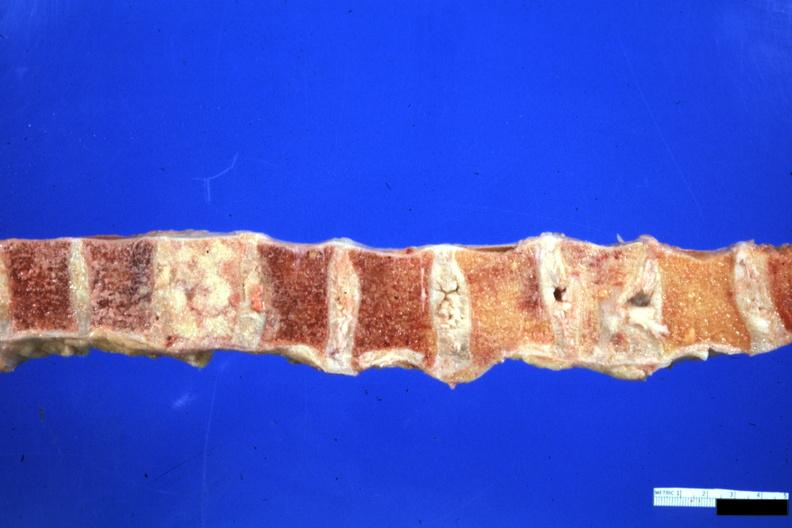what is present?
Answer the question using a single word or phrase. Joints 